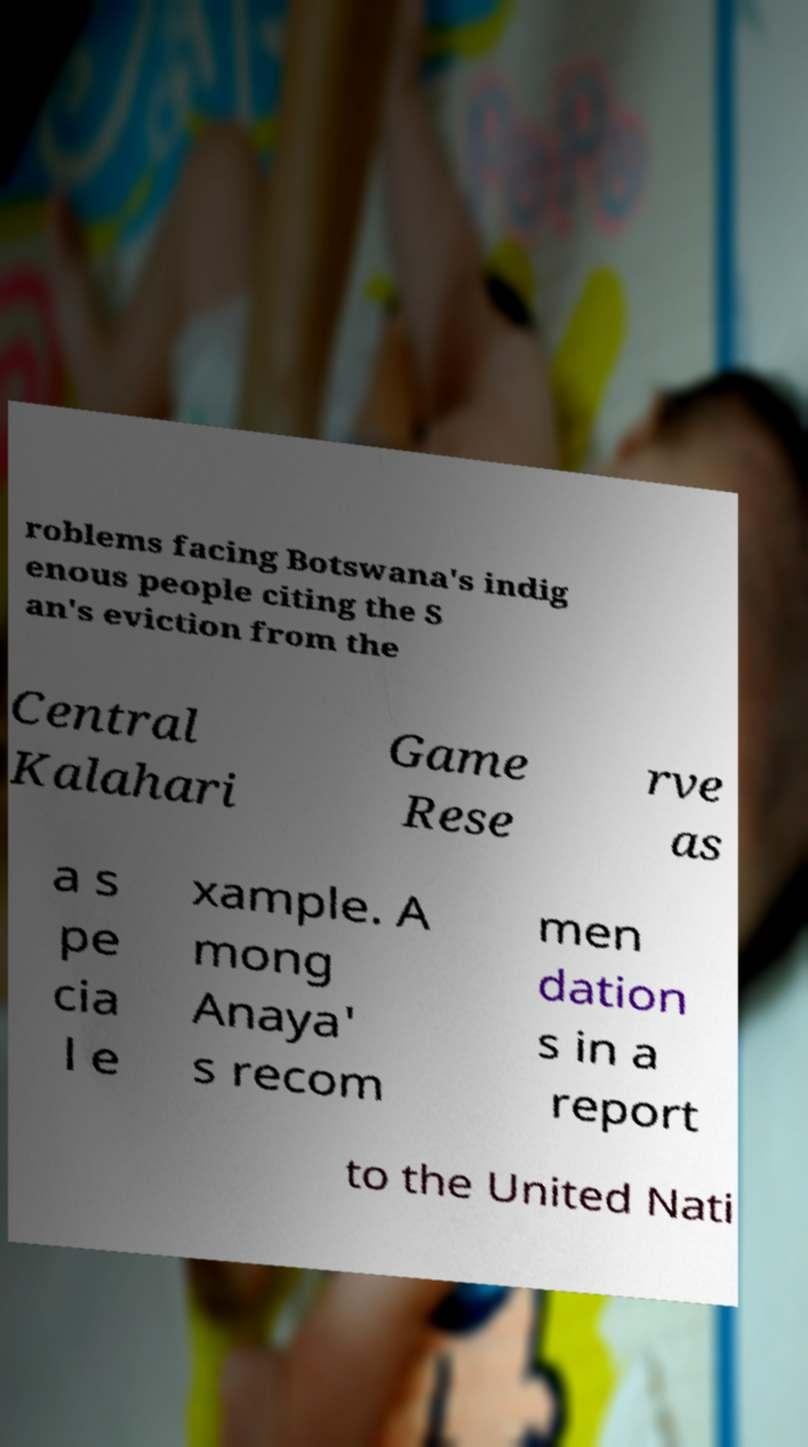Could you assist in decoding the text presented in this image and type it out clearly? roblems facing Botswana's indig enous people citing the S an's eviction from the Central Kalahari Game Rese rve as a s pe cia l e xample. A mong Anaya' s recom men dation s in a report to the United Nati 